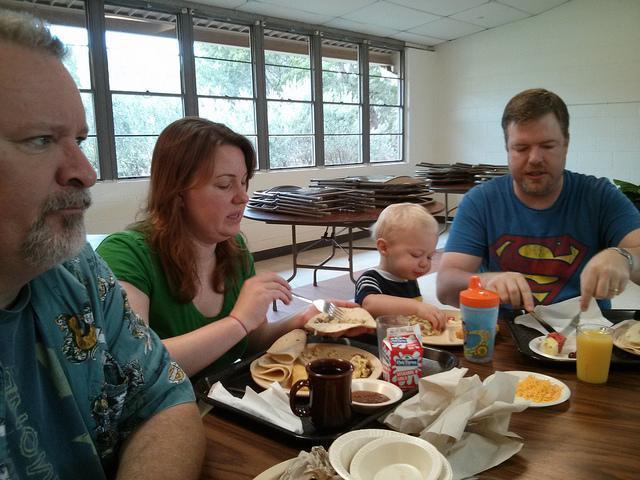What did the man with an S on his shirt likely read when he was young?
Make your selection from the four choices given to correctly answer the question.
Options: Bible, poe, comic books, edith wharton. Comic books. 